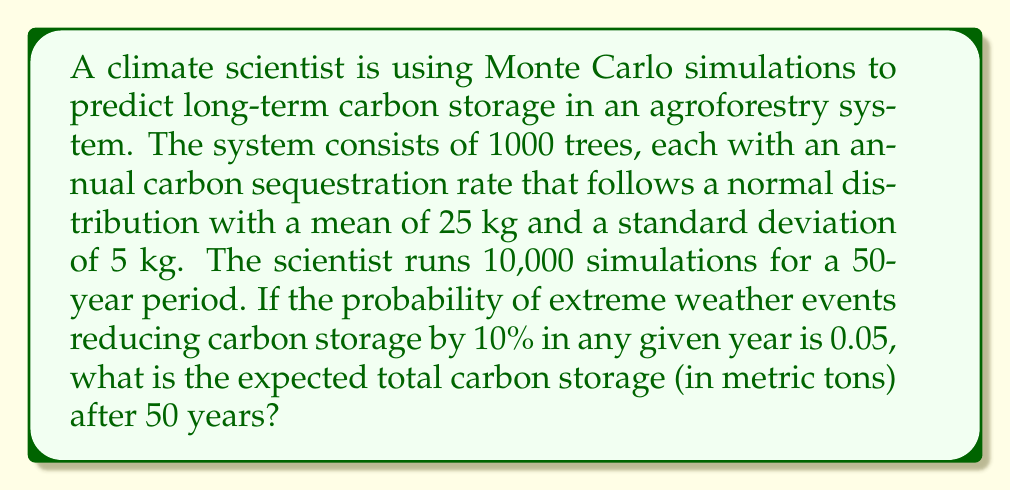Solve this math problem. Let's break this down step-by-step:

1) First, we need to calculate the expected annual carbon sequestration per tree:
   $\mu = 25$ kg/year

2) For 1000 trees over 50 years without extreme events:
   Expected storage = $1000 \text{ trees} \times 50 \text{ years} \times 25 \text{ kg/year} = 1,250,000 \text{ kg}$

3) Now, we need to account for the extreme weather events:
   Probability of an extreme event in any year = 0.05
   Probability of no extreme event = 0.95

4) The expected value of the carbon storage factor due to extreme events over 50 years:
   $E(\text{storage factor}) = (0.95 + 0.05 \times 0.9)^{50} \approx 0.7769$

5) Therefore, the expected total carbon storage:
   $1,250,000 \text{ kg} \times 0.7769 \approx 971,125 \text{ kg}$

6) Converting to metric tons:
   $971,125 \text{ kg} \div 1000 \text{ kg/ton} \approx 971.13 \text{ metric tons}$

The Monte Carlo simulation would involve:
- Generating 1000 random values from $N(25, 5^2)$ for each year
- Summing these values for each year
- Applying a 10% reduction with 0.05 probability each year
- Repeating this process 10,000 times
- Taking the average of these 10,000 results

The analytical solution we calculated (971.13 metric tons) should closely match the result of the Monte Carlo simulation.
Answer: 971.13 metric tons 